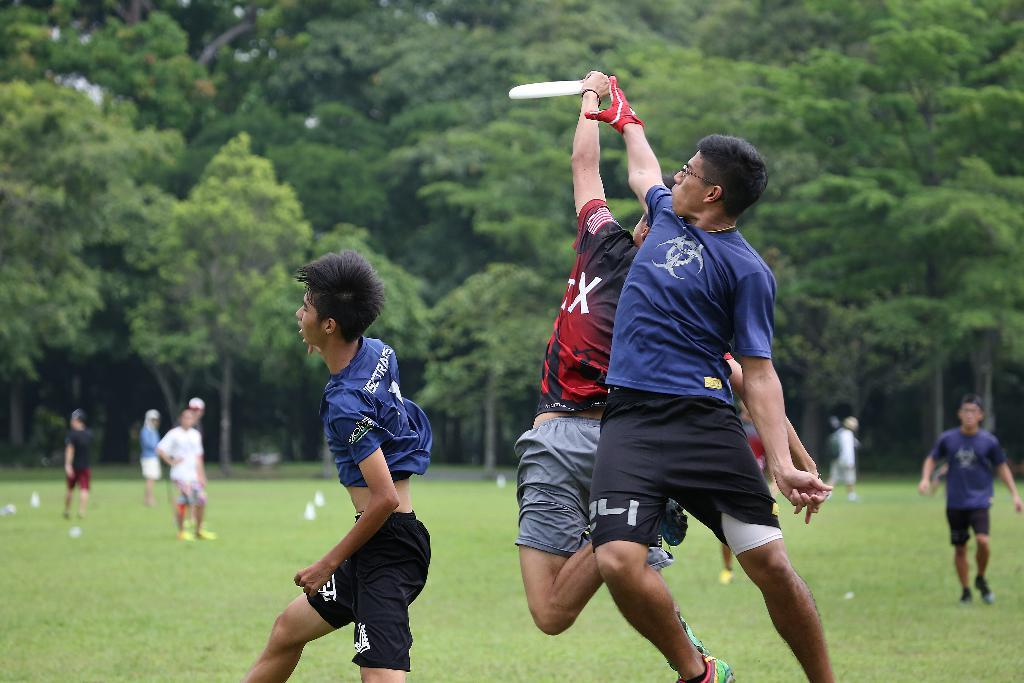<image>
Describe the image concisely. A person in black and red wearing the letter X leaps to catch a frisbee over a defender in blue. 